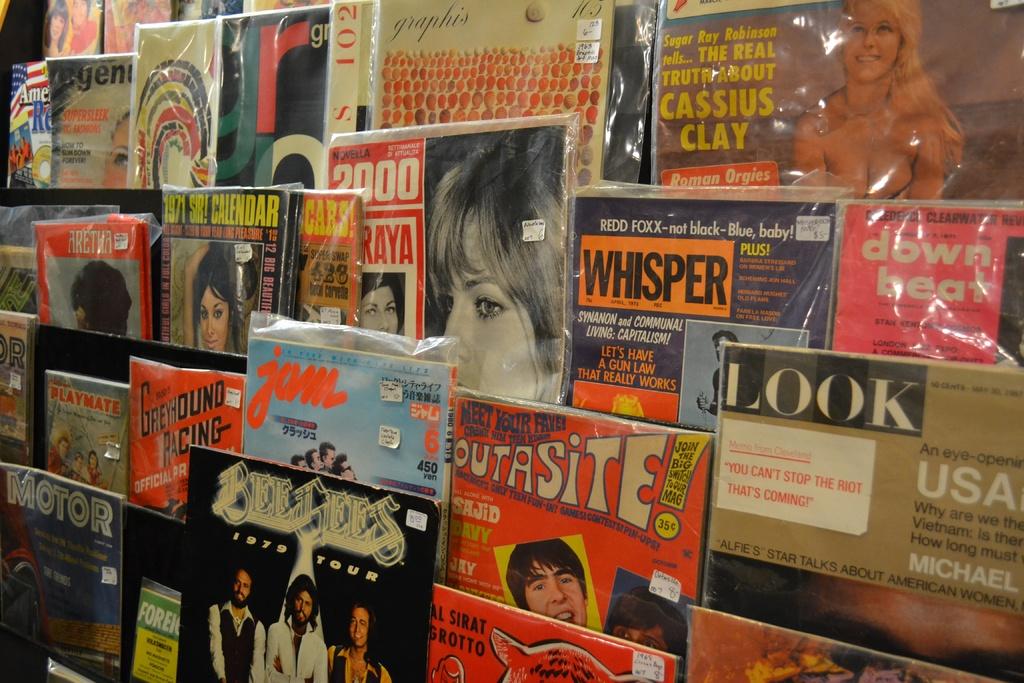What is the headline on look magazine?
Your answer should be very brief. You can't stop the riot that's coming. 